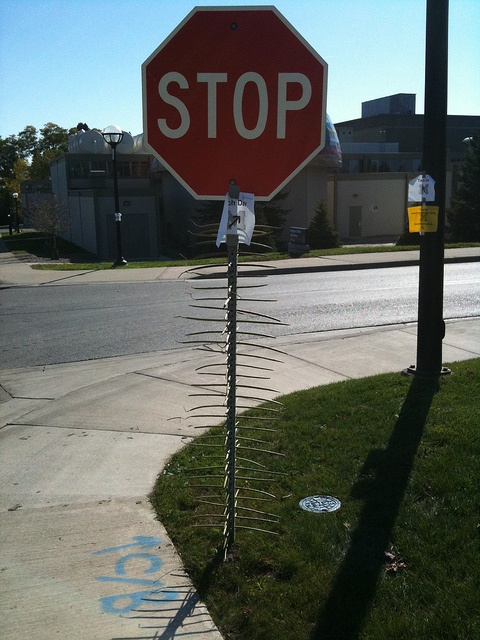Describe the objects in this image and their specific colors. I can see a stop sign in lightblue, black, maroon, and gray tones in this image. 